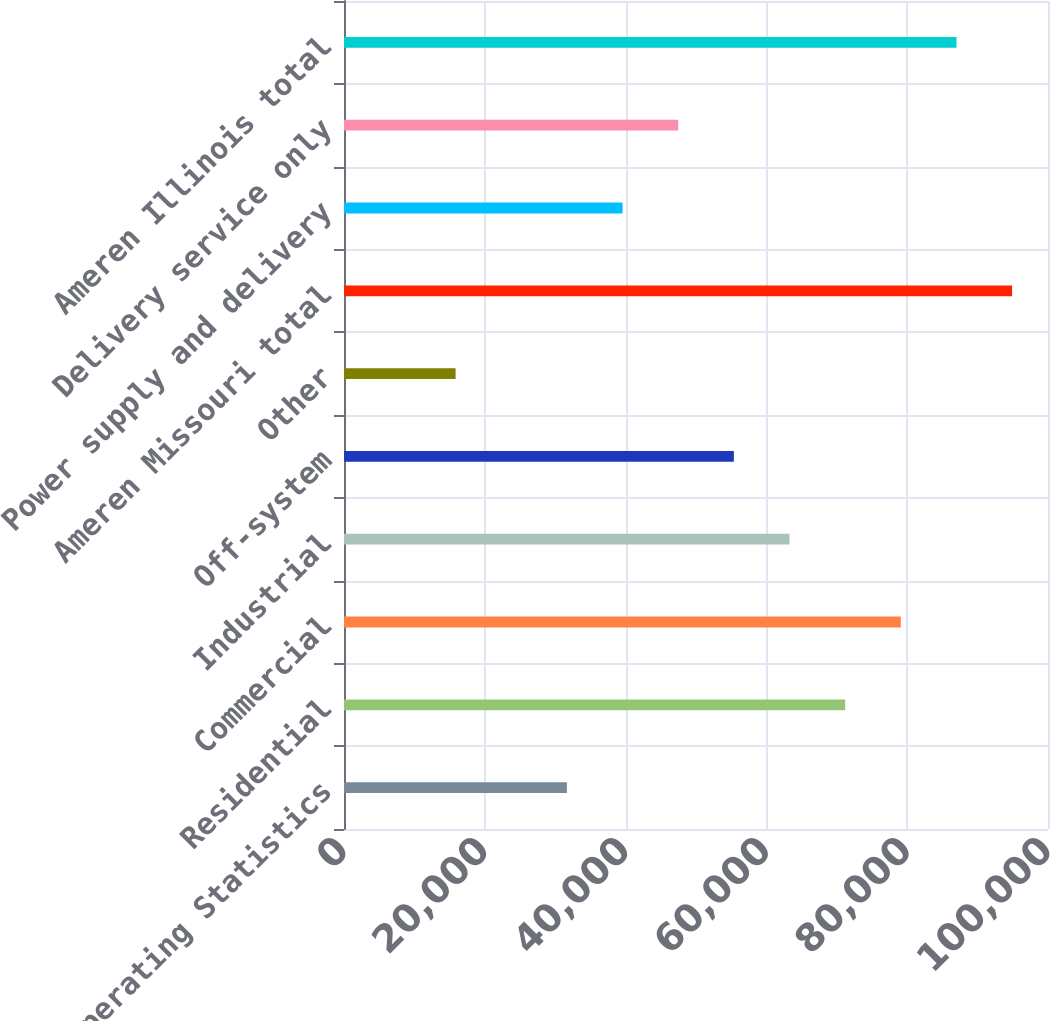Convert chart to OTSL. <chart><loc_0><loc_0><loc_500><loc_500><bar_chart><fcel>Electric Operating Statistics<fcel>Residential<fcel>Commercial<fcel>Industrial<fcel>Off-system<fcel>Other<fcel>Ameren Missouri total<fcel>Power supply and delivery<fcel>Delivery service only<fcel>Ameren Illinois total<nl><fcel>31662.6<fcel>71187.1<fcel>79092<fcel>63282.2<fcel>55377.3<fcel>15852.8<fcel>94901.8<fcel>39567.5<fcel>47472.4<fcel>86996.9<nl></chart> 